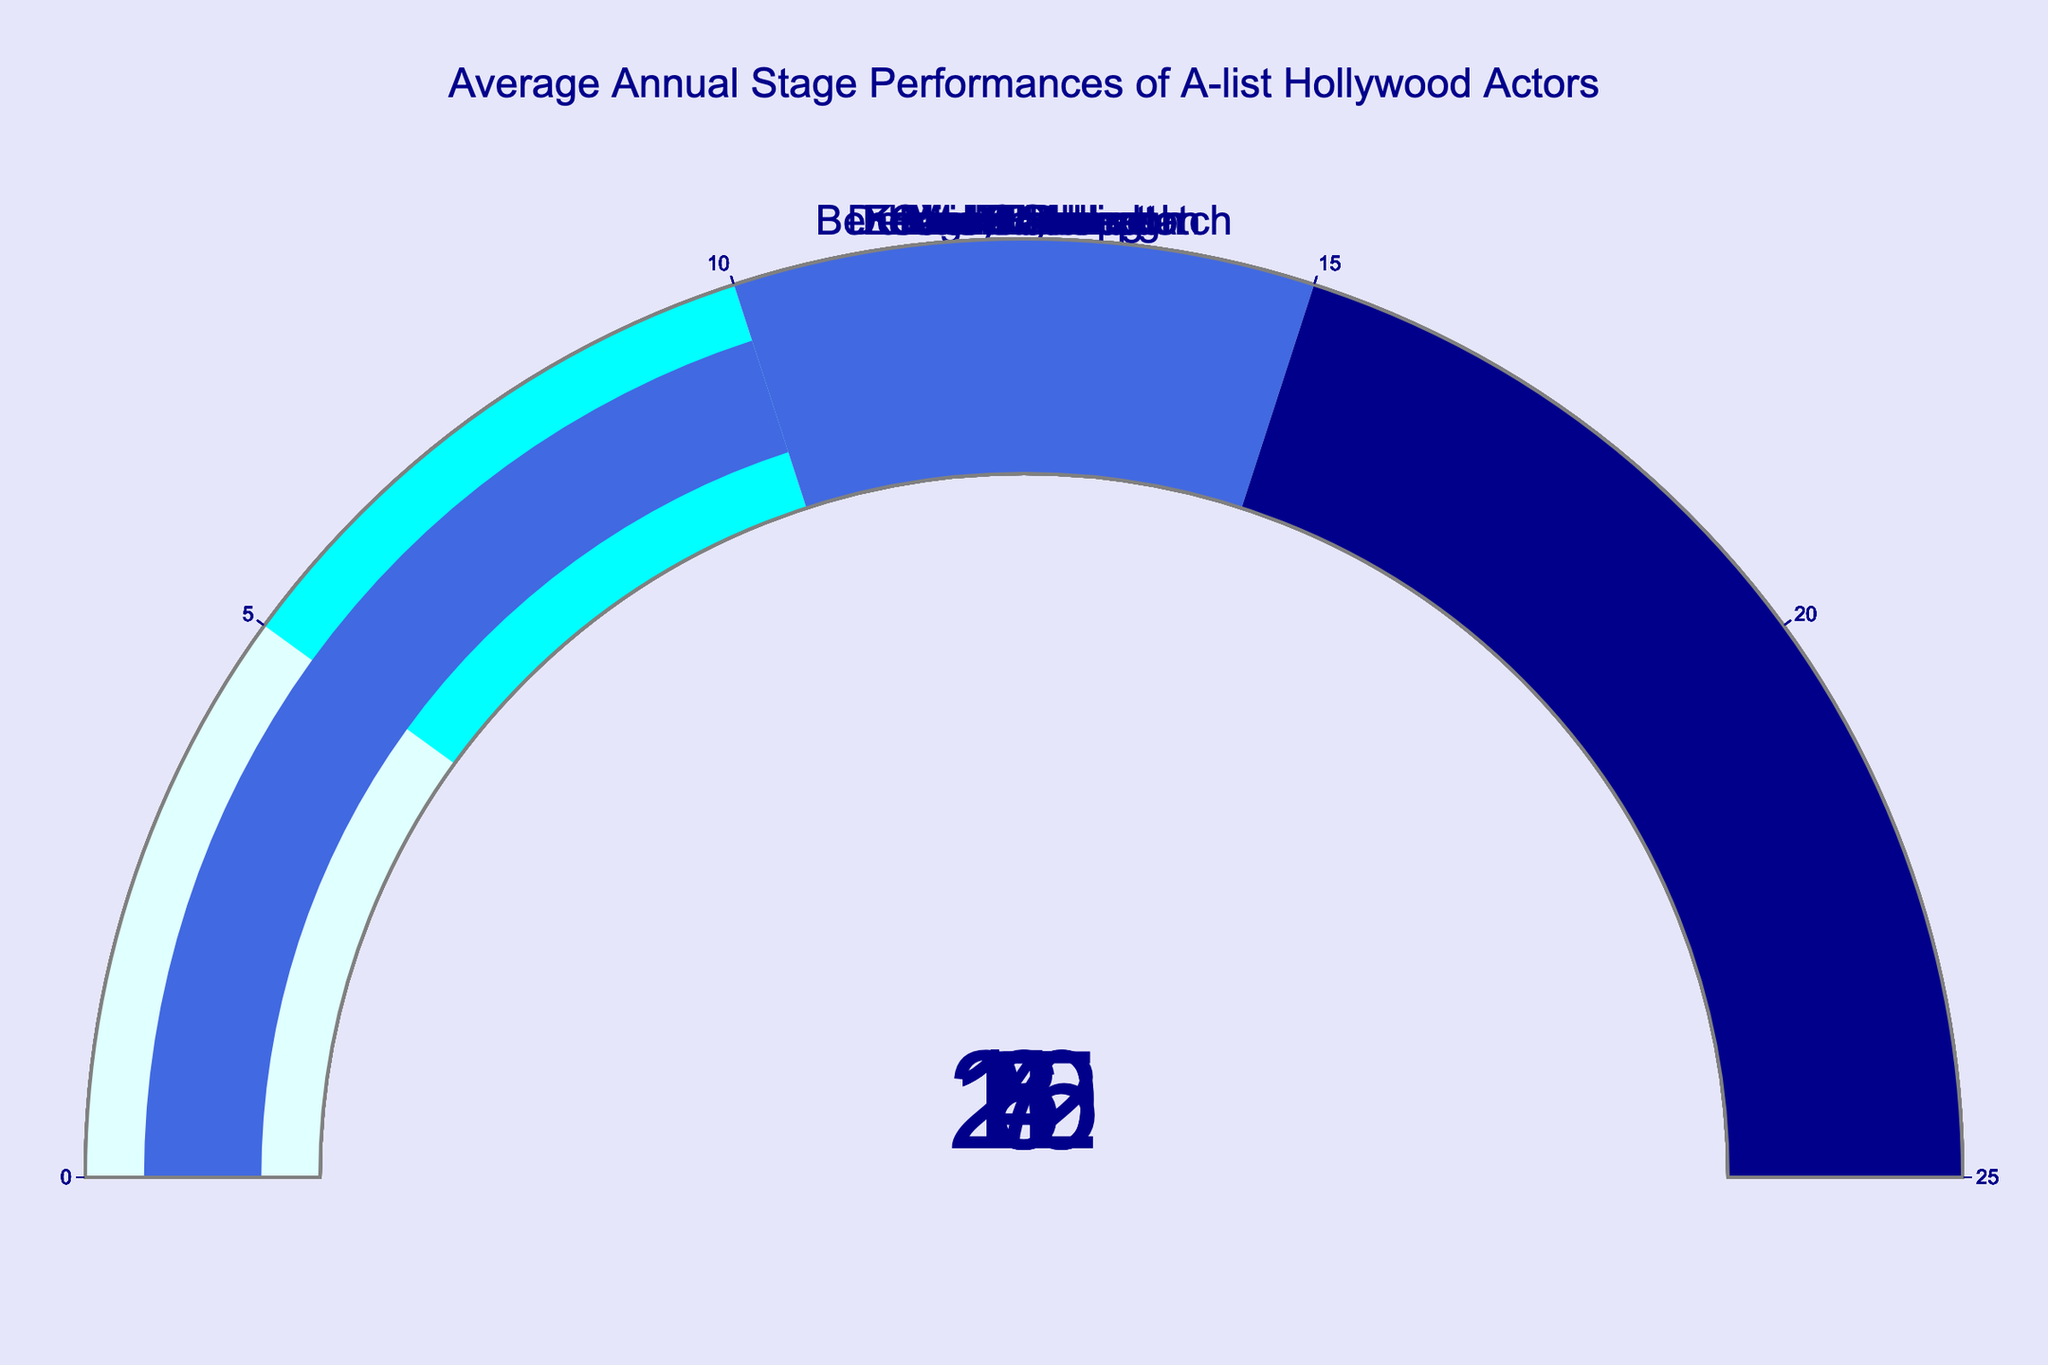What is the title of the gauge chart? The chart's title is displayed at the top center of the figure, and it states the subject of the data.
Answer: Average Annual Stage Performances of A-list Hollywood Actors How many actors have more than 10 stage performances per year? To determine this, we count the number of actors whose gauge value is greater than 10. For this chart, those actors are Hugh Jackman, Ian McKellen, Mark Rylance, and Kenneth Branagh.
Answer: 4 Which actor has the highest average number of stage performances per year? The actor with the highest gauge value on the chart will have the highest average number of stage performances per year. Mark Rylance has the highest value of 20 performances.
Answer: Mark Rylance What is the color range for the gauge value of 15? The gauge chart uses different colors for different ranges. From the visual information, we can see that the range 15-25 is colored in dark blue.
Answer: Dark blue What is the median number of annual stage performances among the actors? The median is the middle value when the data points are ordered. The ordered values are: 3, 4, 5, 6, 7, 8, 10, 12, 15, 20. The median is the average of the 5th and 6th values (7 and 8). (7+8)/2 = 7.5
Answer: 7.5 How many actors have fewer stage performances per year than Viola Davis? Viola Davis has 7 stage performances per year. Comparing this to other actors: Benedict Cumberbatch, Denzel Washington, and Emma Thompson have fewer performances.
Answer: 3 What is the range of stage performances per year for the actors? This involves finding the difference between the highest and lowest gauge values. The highest is 20 (Mark Rylance) and the lowest is 3 (Denzel Washington). 20 - 3 = 17
Answer: 17 How many actors fall within the cyan color range on the gauge? The cyan color range on the gauge covers 5-10 performances. Actors falling within this range are Meryl Streep, Cate Blanchett, Viola Davis, and Kenneth Branagh.
Answer: 4 